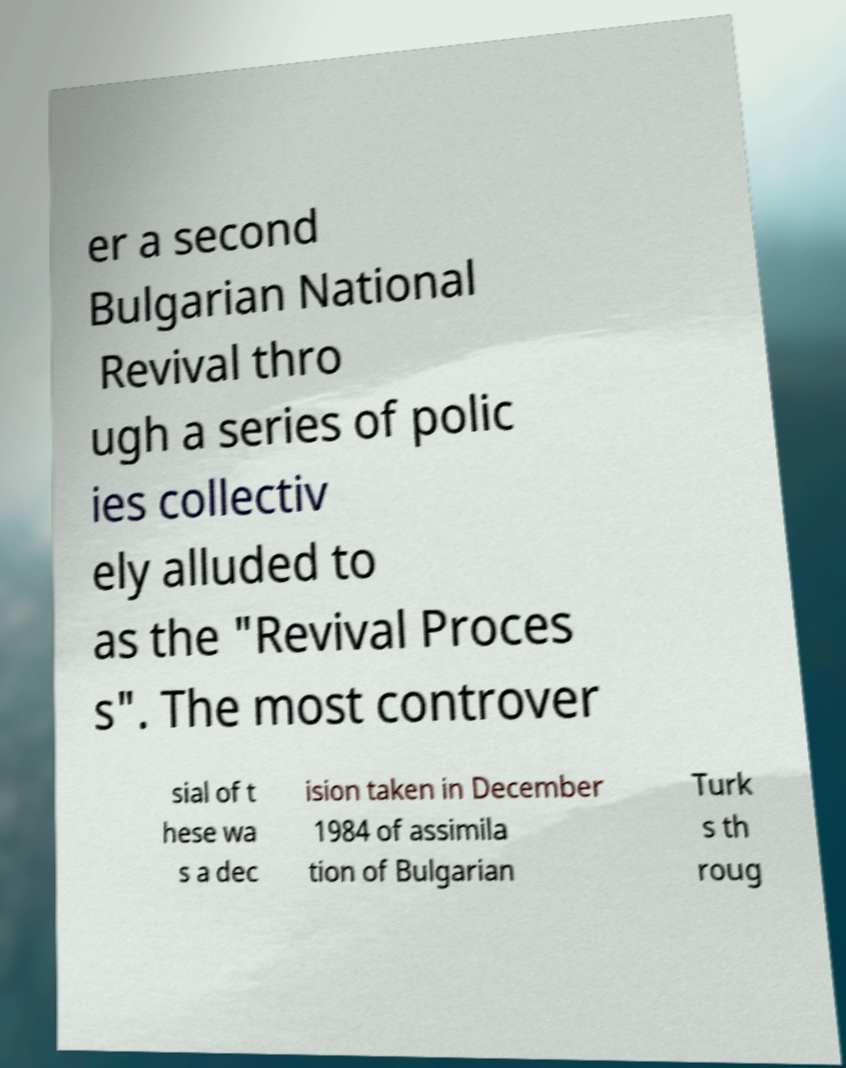Could you assist in decoding the text presented in this image and type it out clearly? er a second Bulgarian National Revival thro ugh a series of polic ies collectiv ely alluded to as the "Revival Proces s". The most controver sial of t hese wa s a dec ision taken in December 1984 of assimila tion of Bulgarian Turk s th roug 